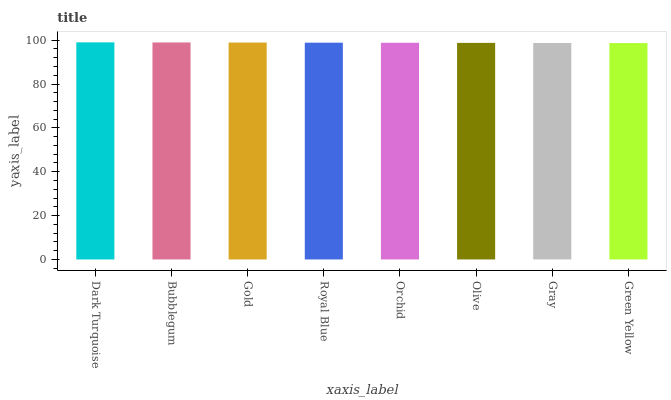Is Green Yellow the minimum?
Answer yes or no. Yes. Is Dark Turquoise the maximum?
Answer yes or no. Yes. Is Bubblegum the minimum?
Answer yes or no. No. Is Bubblegum the maximum?
Answer yes or no. No. Is Dark Turquoise greater than Bubblegum?
Answer yes or no. Yes. Is Bubblegum less than Dark Turquoise?
Answer yes or no. Yes. Is Bubblegum greater than Dark Turquoise?
Answer yes or no. No. Is Dark Turquoise less than Bubblegum?
Answer yes or no. No. Is Royal Blue the high median?
Answer yes or no. Yes. Is Orchid the low median?
Answer yes or no. Yes. Is Orchid the high median?
Answer yes or no. No. Is Bubblegum the low median?
Answer yes or no. No. 